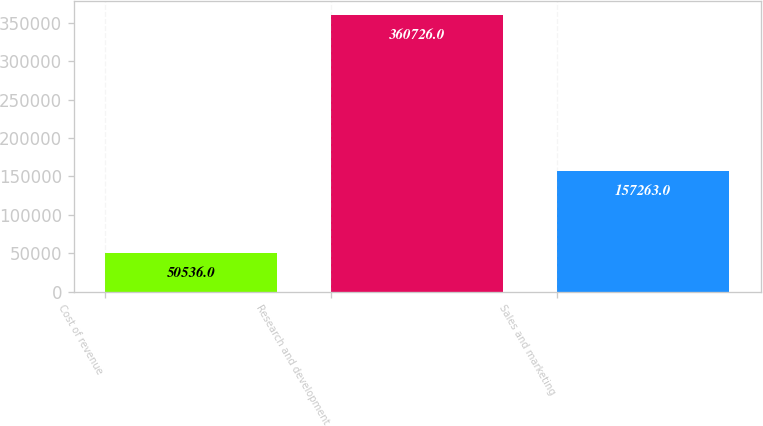<chart> <loc_0><loc_0><loc_500><loc_500><bar_chart><fcel>Cost of revenue<fcel>Research and development<fcel>Sales and marketing<nl><fcel>50536<fcel>360726<fcel>157263<nl></chart> 